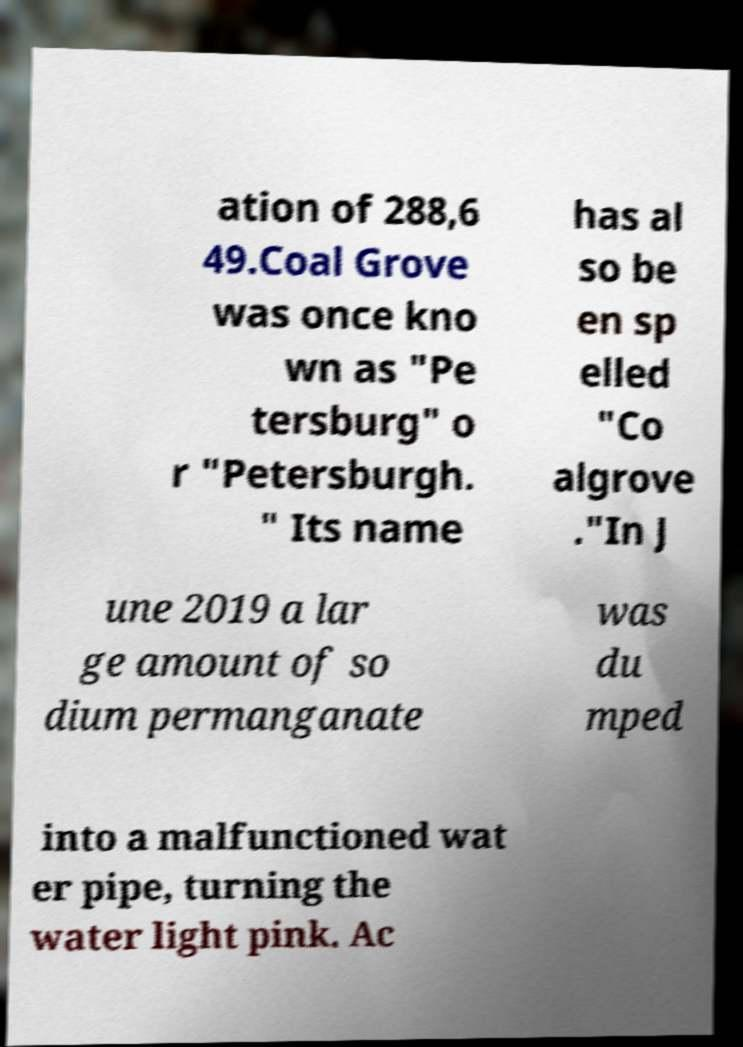What messages or text are displayed in this image? I need them in a readable, typed format. ation of 288,6 49.Coal Grove was once kno wn as "Pe tersburg" o r "Petersburgh. " Its name has al so be en sp elled "Co algrove ."In J une 2019 a lar ge amount of so dium permanganate was du mped into a malfunctioned wat er pipe, turning the water light pink. Ac 